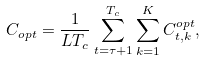Convert formula to latex. <formula><loc_0><loc_0><loc_500><loc_500>C _ { o p t } = \frac { 1 } { L T _ { c } } \sum _ { t = \tau + 1 } ^ { T _ { c } } \sum _ { k = 1 } ^ { K } C _ { t , k } ^ { o p t } ,</formula> 